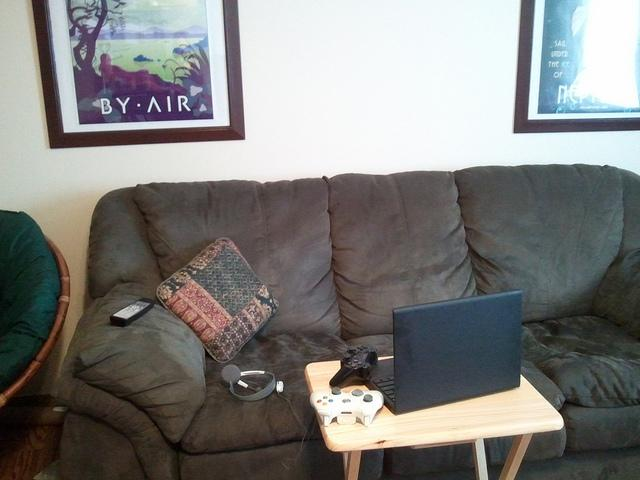Which gaming system is the white remote for on the table?

Choices:
A) gamecube
B) playstation
C) xbox
D) nintendo wii xbox 